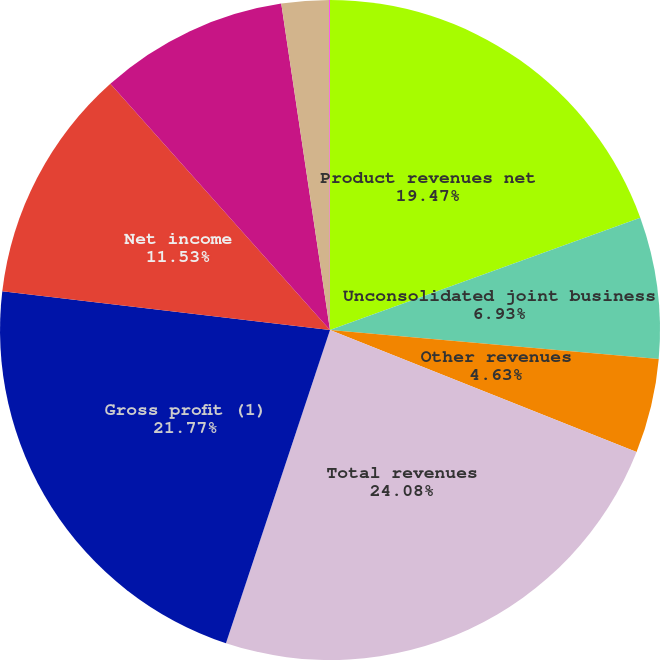Convert chart to OTSL. <chart><loc_0><loc_0><loc_500><loc_500><pie_chart><fcel>Product revenues net<fcel>Unconsolidated joint business<fcel>Other revenues<fcel>Total revenues<fcel>Gross profit (1)<fcel>Net income<fcel>Net income attributable to<fcel>Basic earnings per share<fcel>Diluted earnings per share<nl><fcel>19.47%<fcel>6.93%<fcel>4.63%<fcel>24.07%<fcel>21.77%<fcel>11.53%<fcel>9.23%<fcel>2.33%<fcel>0.03%<nl></chart> 